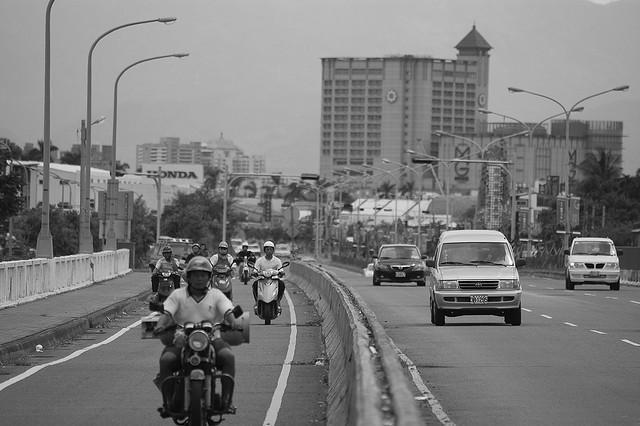How many cars are there?
Give a very brief answer. 2. 